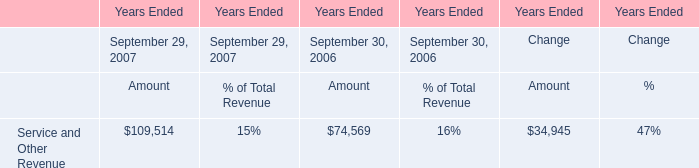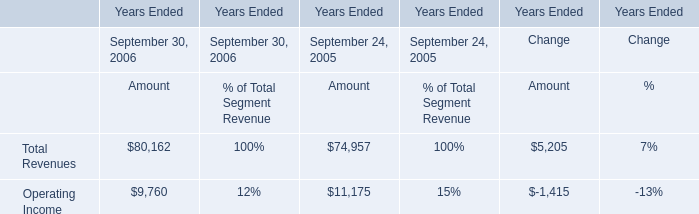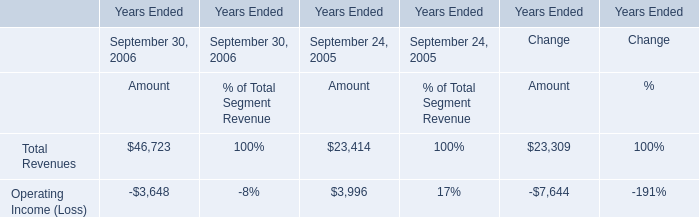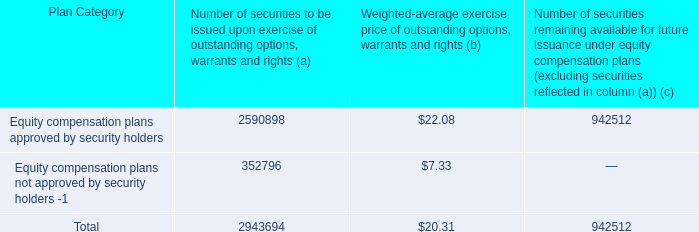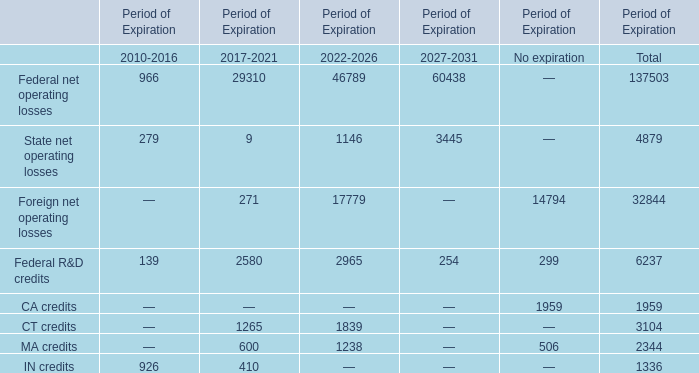How many elements for the Period of Expiration 2017-2021 is more than 10? 
Answer: 6. 